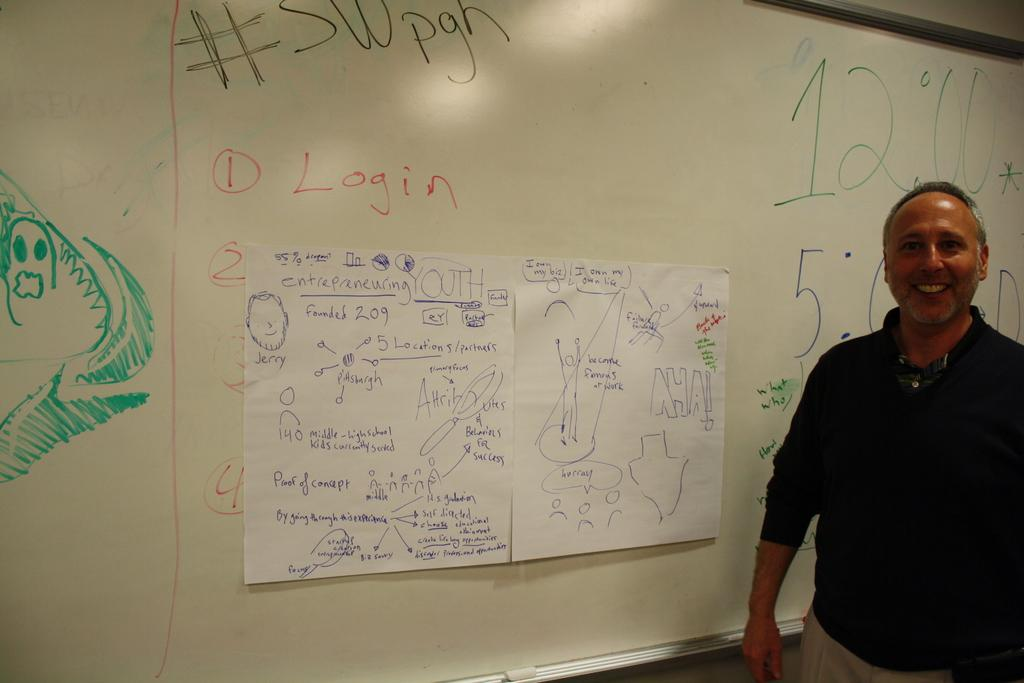<image>
Write a terse but informative summary of the picture. the number 12 is on a board behind a guy 